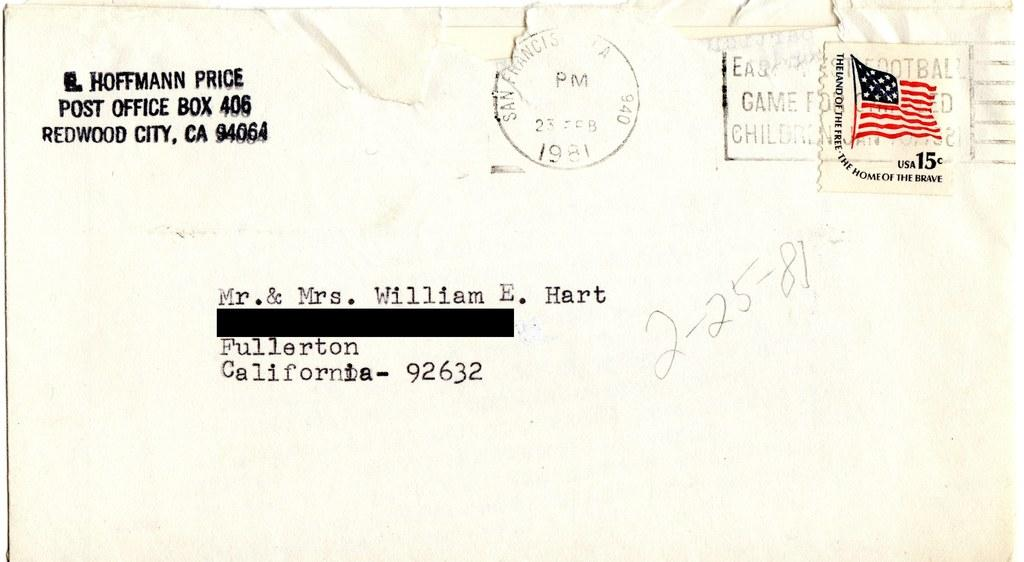Provide a one-sentence caption for the provided image. The envelope is addressed to Mr. & Mrs. William E. Hart and was postmarked 1981. 